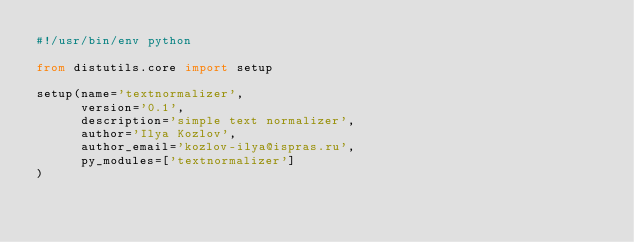<code> <loc_0><loc_0><loc_500><loc_500><_Python_>#!/usr/bin/env python

from distutils.core import setup

setup(name='textnormalizer',
      version='0.1',
      description='simple text normalizer',
      author='Ilya Kozlov',
      author_email='kozlov-ilya@ispras.ru',
      py_modules=['textnormalizer']
)
</code> 